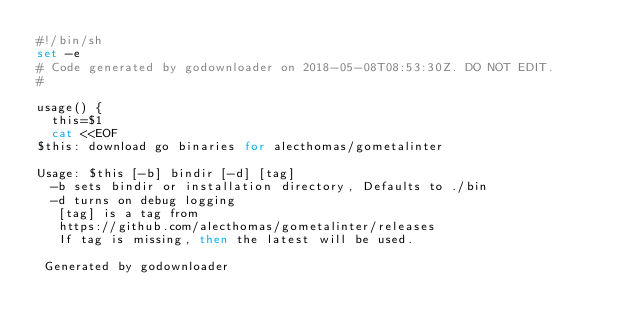Convert code to text. <code><loc_0><loc_0><loc_500><loc_500><_Bash_>#!/bin/sh
set -e
# Code generated by godownloader on 2018-05-08T08:53:30Z. DO NOT EDIT.
#

usage() {
  this=$1
  cat <<EOF
$this: download go binaries for alecthomas/gometalinter

Usage: $this [-b] bindir [-d] [tag]
  -b sets bindir or installation directory, Defaults to ./bin
  -d turns on debug logging
   [tag] is a tag from
   https://github.com/alecthomas/gometalinter/releases
   If tag is missing, then the latest will be used.

 Generated by godownloader</code> 